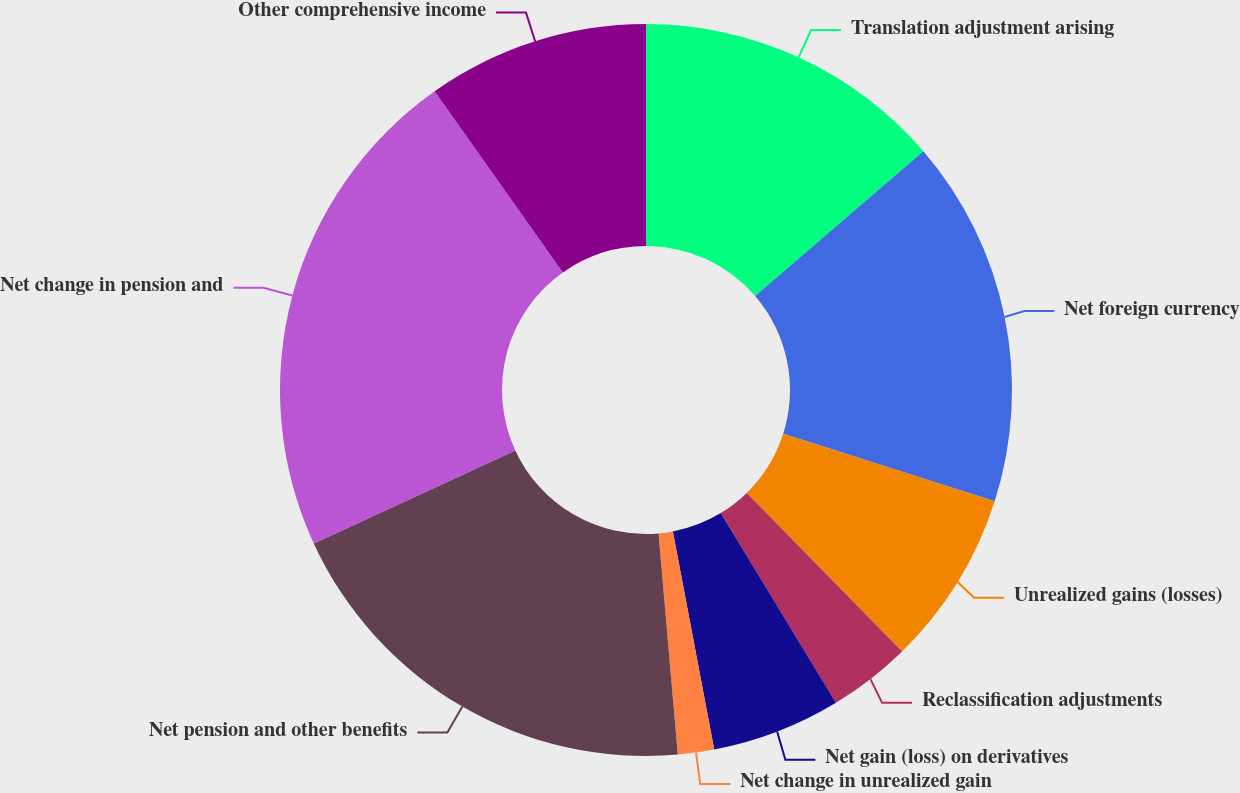Convert chart to OTSL. <chart><loc_0><loc_0><loc_500><loc_500><pie_chart><fcel>Translation adjustment arising<fcel>Net foreign currency<fcel>Unrealized gains (losses)<fcel>Reclassification adjustments<fcel>Net gain (loss) on derivatives<fcel>Net change in unrealized gain<fcel>Net pension and other benefits<fcel>Net change in pension and<fcel>Other comprehensive income<nl><fcel>13.69%<fcel>16.23%<fcel>7.75%<fcel>3.65%<fcel>5.7%<fcel>1.6%<fcel>19.5%<fcel>22.09%<fcel>9.8%<nl></chart> 